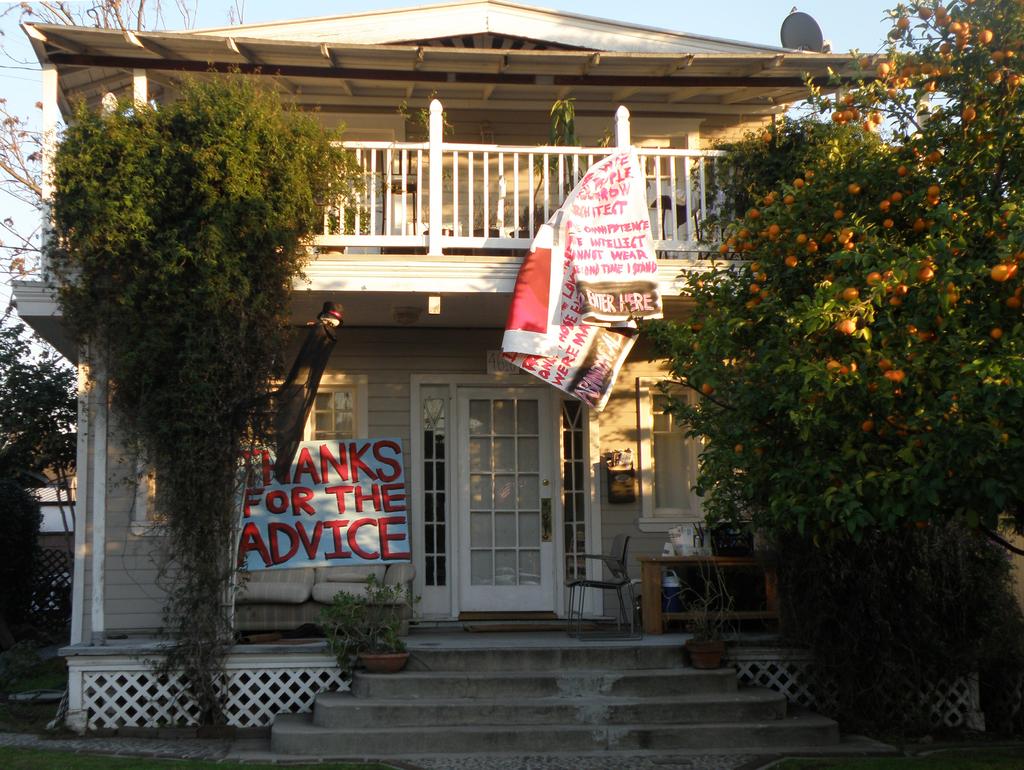What the sign thanking someone for?
Your response must be concise. Advice. 